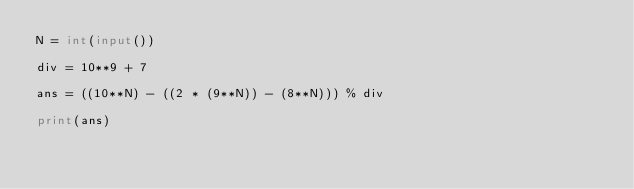Convert code to text. <code><loc_0><loc_0><loc_500><loc_500><_Python_>N = int(input())

div = 10**9 + 7

ans = ((10**N) - ((2 * (9**N)) - (8**N))) % div

print(ans)</code> 